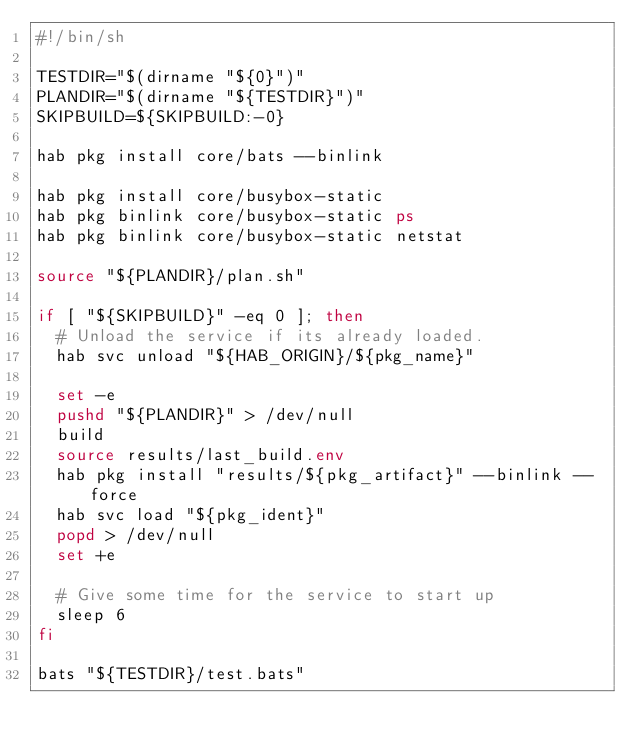Convert code to text. <code><loc_0><loc_0><loc_500><loc_500><_Bash_>#!/bin/sh

TESTDIR="$(dirname "${0}")"
PLANDIR="$(dirname "${TESTDIR}")"
SKIPBUILD=${SKIPBUILD:-0}

hab pkg install core/bats --binlink

hab pkg install core/busybox-static
hab pkg binlink core/busybox-static ps
hab pkg binlink core/busybox-static netstat

source "${PLANDIR}/plan.sh"

if [ "${SKIPBUILD}" -eq 0 ]; then
  # Unload the service if its already loaded.
  hab svc unload "${HAB_ORIGIN}/${pkg_name}"

  set -e
  pushd "${PLANDIR}" > /dev/null
  build
  source results/last_build.env
  hab pkg install "results/${pkg_artifact}" --binlink --force
  hab svc load "${pkg_ident}"
  popd > /dev/null
  set +e

  # Give some time for the service to start up
  sleep 6
fi

bats "${TESTDIR}/test.bats"
</code> 